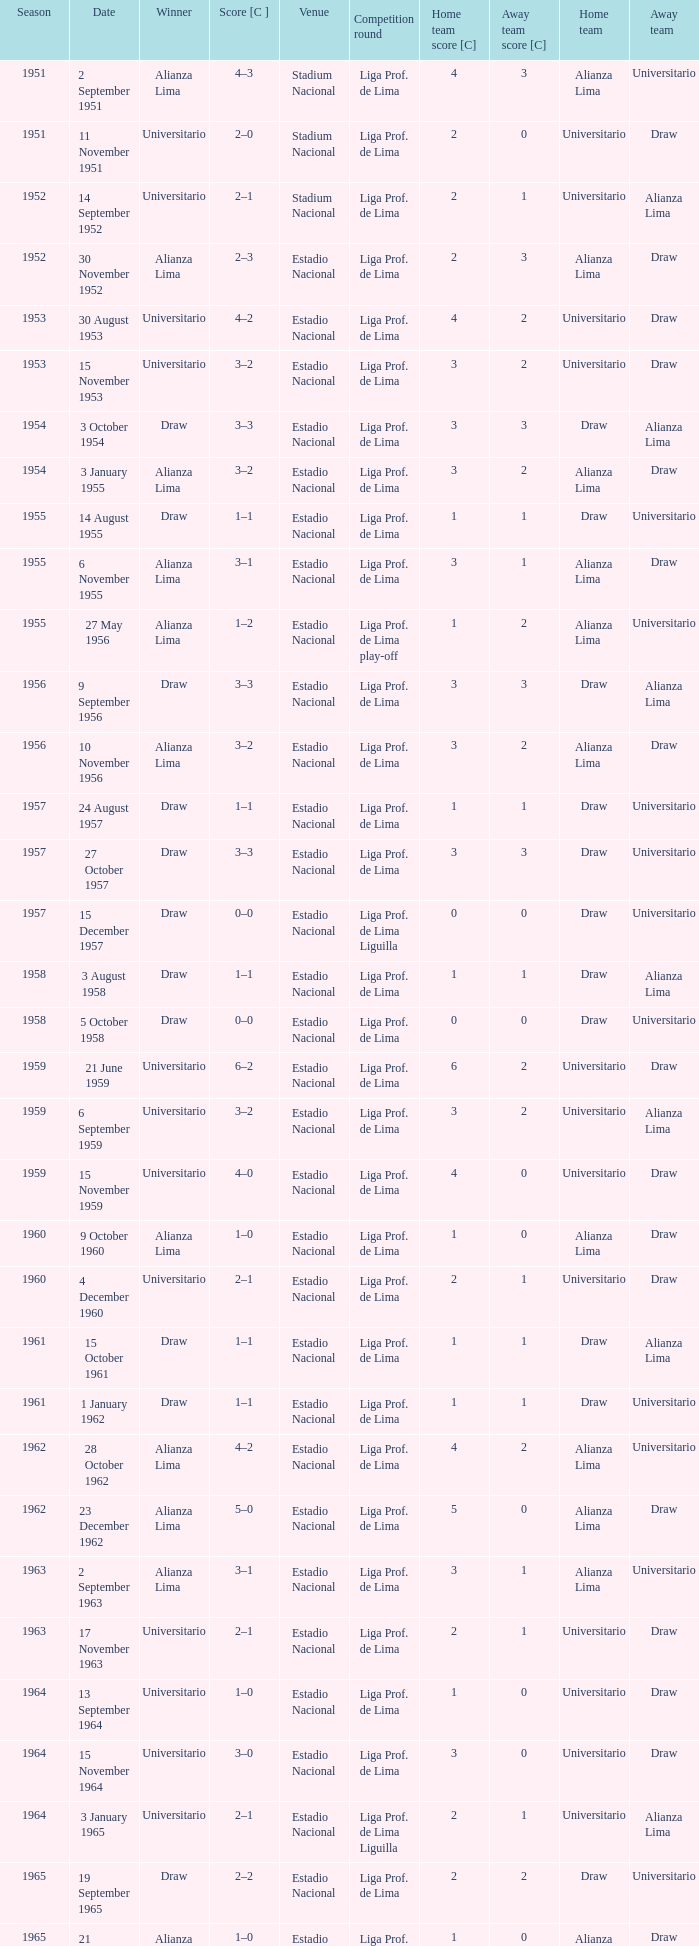What is the score of the event that Alianza Lima won in 1965? 1–0. 